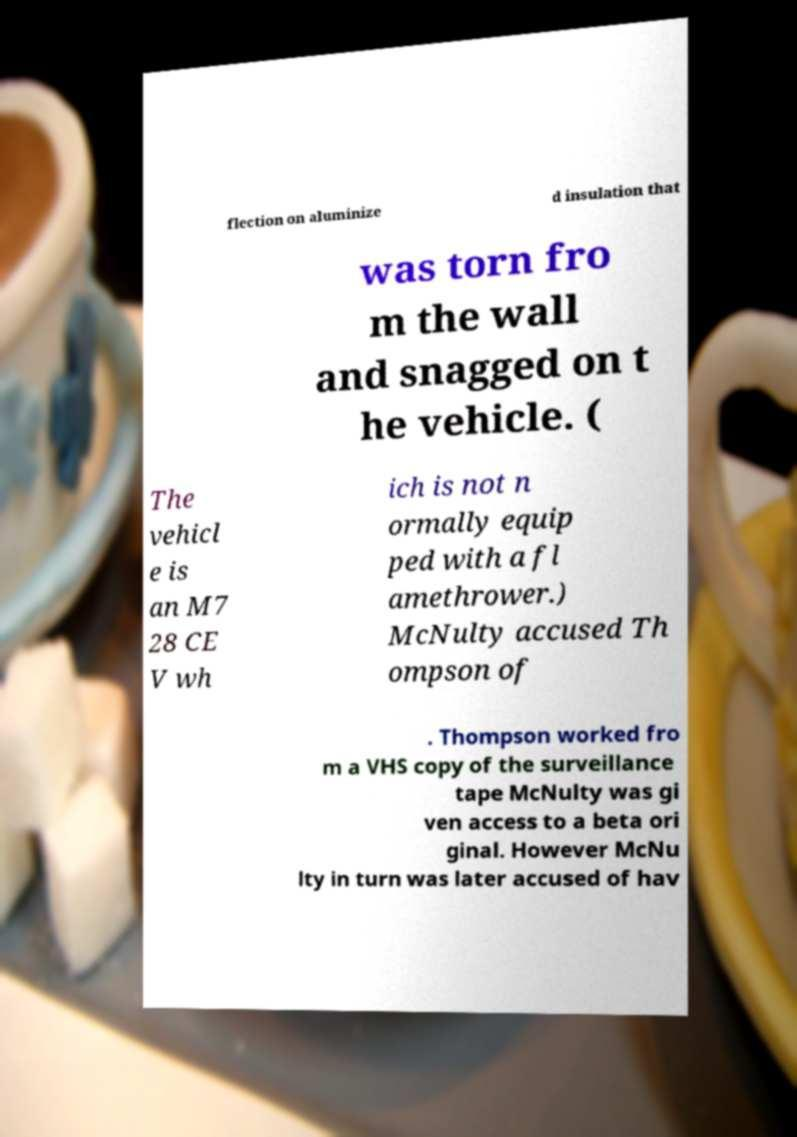Please identify and transcribe the text found in this image. flection on aluminize d insulation that was torn fro m the wall and snagged on t he vehicle. ( The vehicl e is an M7 28 CE V wh ich is not n ormally equip ped with a fl amethrower.) McNulty accused Th ompson of . Thompson worked fro m a VHS copy of the surveillance tape McNulty was gi ven access to a beta ori ginal. However McNu lty in turn was later accused of hav 